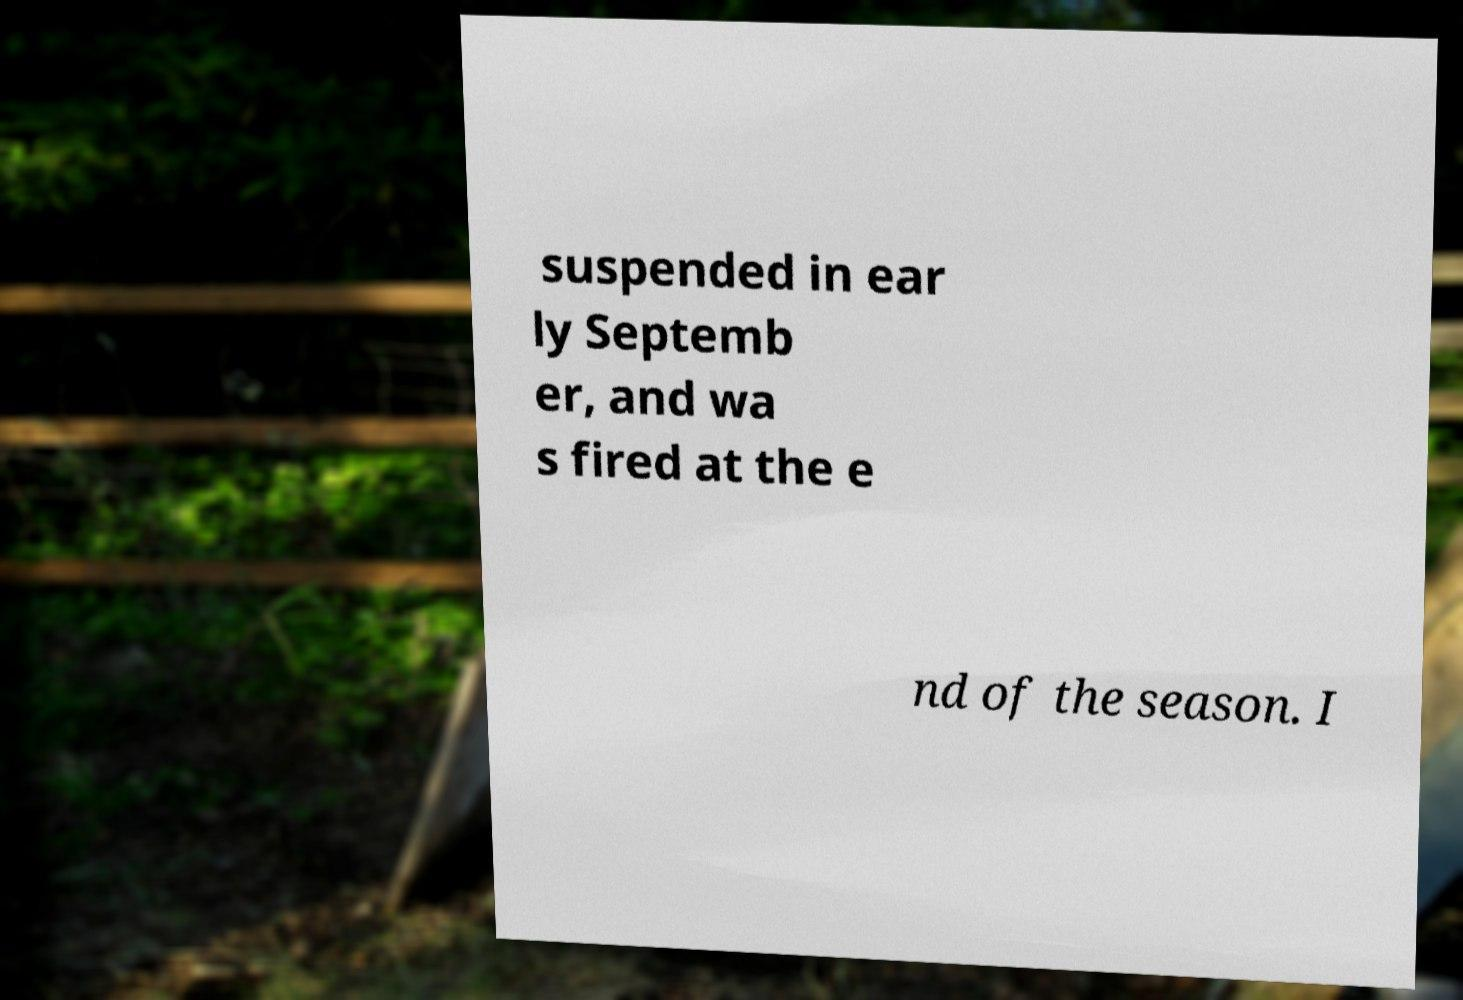Could you extract and type out the text from this image? suspended in ear ly Septemb er, and wa s fired at the e nd of the season. I 